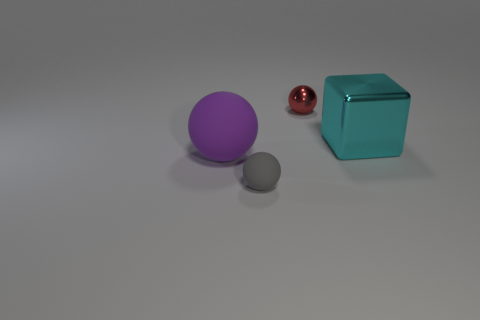What number of other purple objects have the same material as the large purple thing?
Give a very brief answer. 0. What number of other things are there of the same size as the purple thing?
Offer a very short reply. 1. Is there a ball that has the same size as the cyan thing?
Your answer should be very brief. Yes. What number of objects are either tiny red spheres or large cyan rubber blocks?
Keep it short and to the point. 1. There is a rubber sphere in front of the purple matte object; does it have the same size as the red shiny ball?
Give a very brief answer. Yes. How big is the thing that is both behind the large rubber thing and to the left of the big cyan shiny cube?
Make the answer very short. Small. How many other objects are the same shape as the gray rubber object?
Provide a succinct answer. 2. How many other things are there of the same material as the big cyan block?
Your answer should be very brief. 1. What is the size of the gray matte thing that is the same shape as the big purple thing?
Your answer should be very brief. Small. The thing that is both behind the purple matte thing and left of the block is what color?
Offer a terse response. Red. 